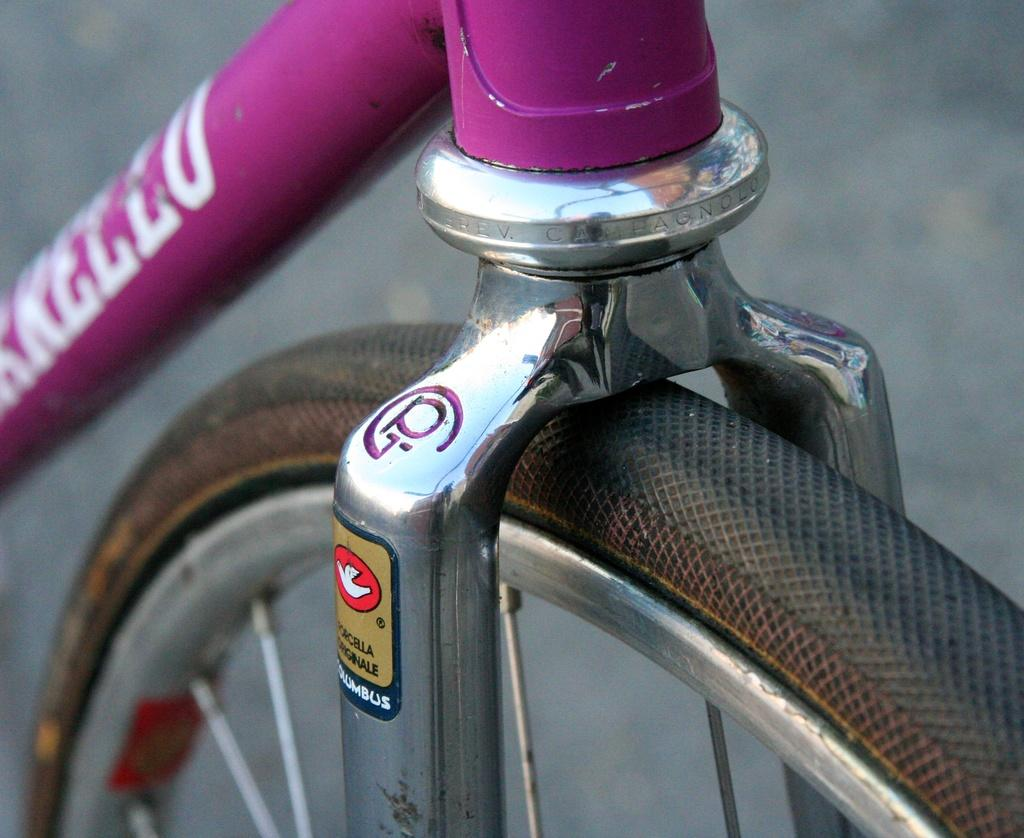What is the main object in the image? There is a bicycle wheel in the image. Are there any other objects visible in the image? Yes, there are rods in the image. Can you describe the background of the image? The background of the image is blurry. How many kittens are playing with the cloth in the image? There are no kittens or cloth present in the image. What type of beetle can be seen crawling on the rods in the image? There are no beetles visible in the image; only the bicycle wheel and rods are present. 